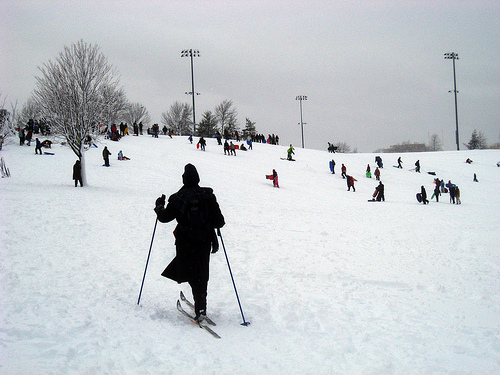Please provide a short description for this region: [0.35, 0.44, 0.41, 0.51]. The head of a person, likely the skier, who is well-dressed for the cold weather. 